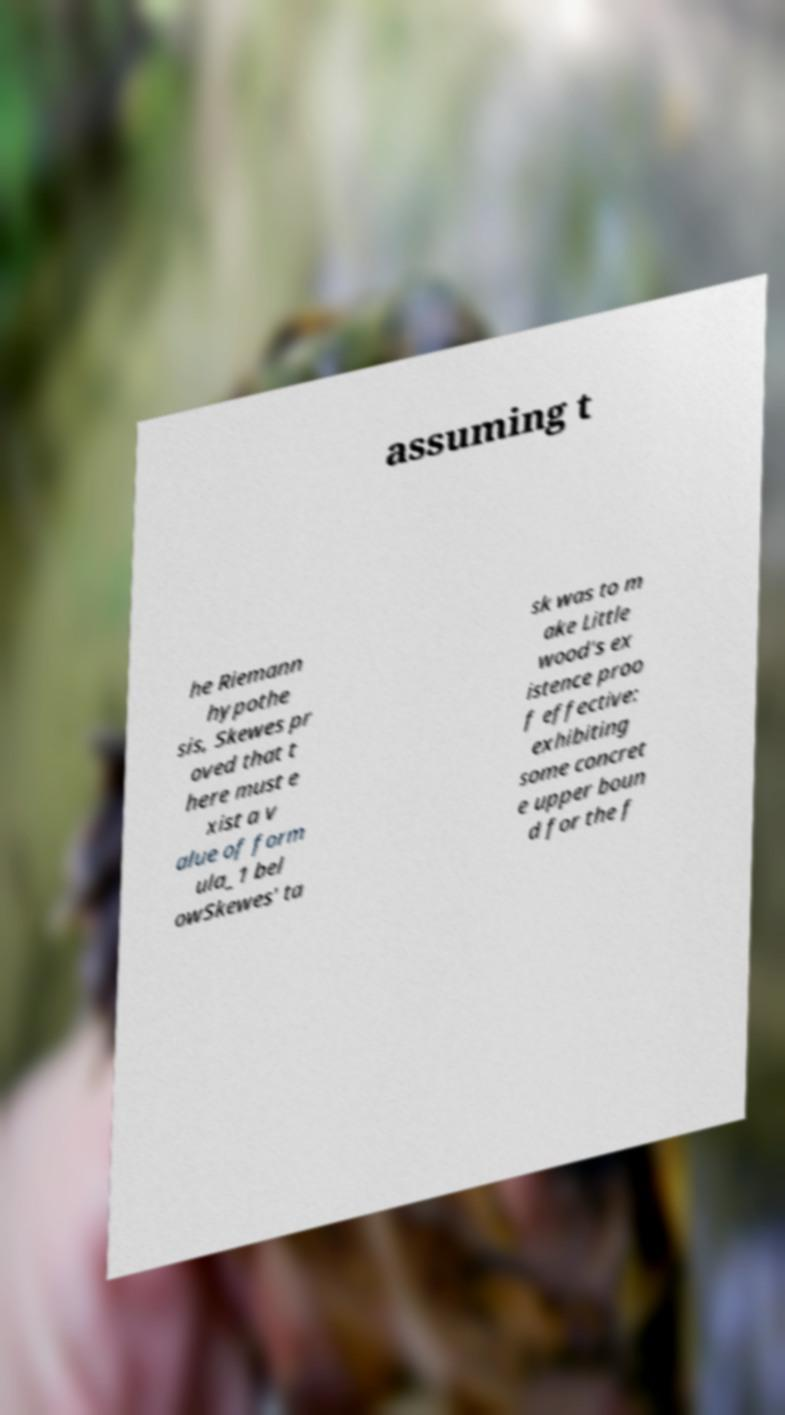Can you accurately transcribe the text from the provided image for me? assuming t he Riemann hypothe sis, Skewes pr oved that t here must e xist a v alue of form ula_1 bel owSkewes' ta sk was to m ake Little wood's ex istence proo f effective: exhibiting some concret e upper boun d for the f 